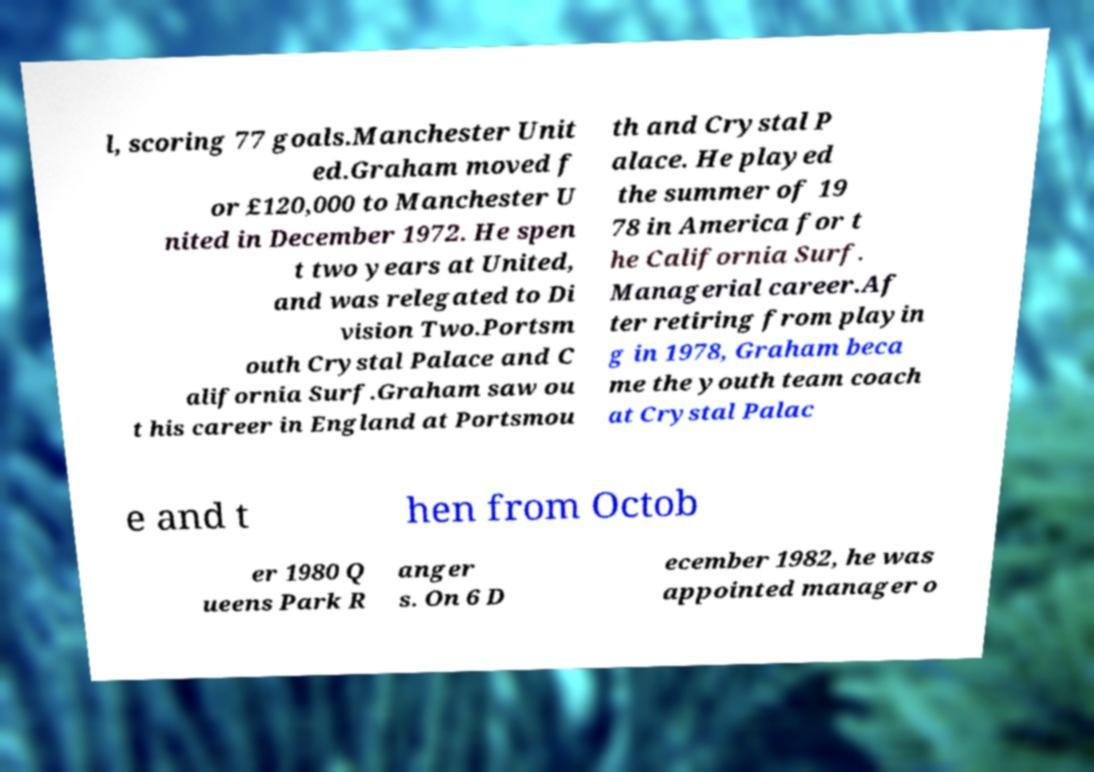Please read and relay the text visible in this image. What does it say? l, scoring 77 goals.Manchester Unit ed.Graham moved f or £120,000 to Manchester U nited in December 1972. He spen t two years at United, and was relegated to Di vision Two.Portsm outh Crystal Palace and C alifornia Surf.Graham saw ou t his career in England at Portsmou th and Crystal P alace. He played the summer of 19 78 in America for t he California Surf. Managerial career.Af ter retiring from playin g in 1978, Graham beca me the youth team coach at Crystal Palac e and t hen from Octob er 1980 Q ueens Park R anger s. On 6 D ecember 1982, he was appointed manager o 